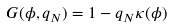Convert formula to latex. <formula><loc_0><loc_0><loc_500><loc_500>G ( \phi , q _ { N } ) = 1 - q _ { N } \kappa ( \phi )</formula> 